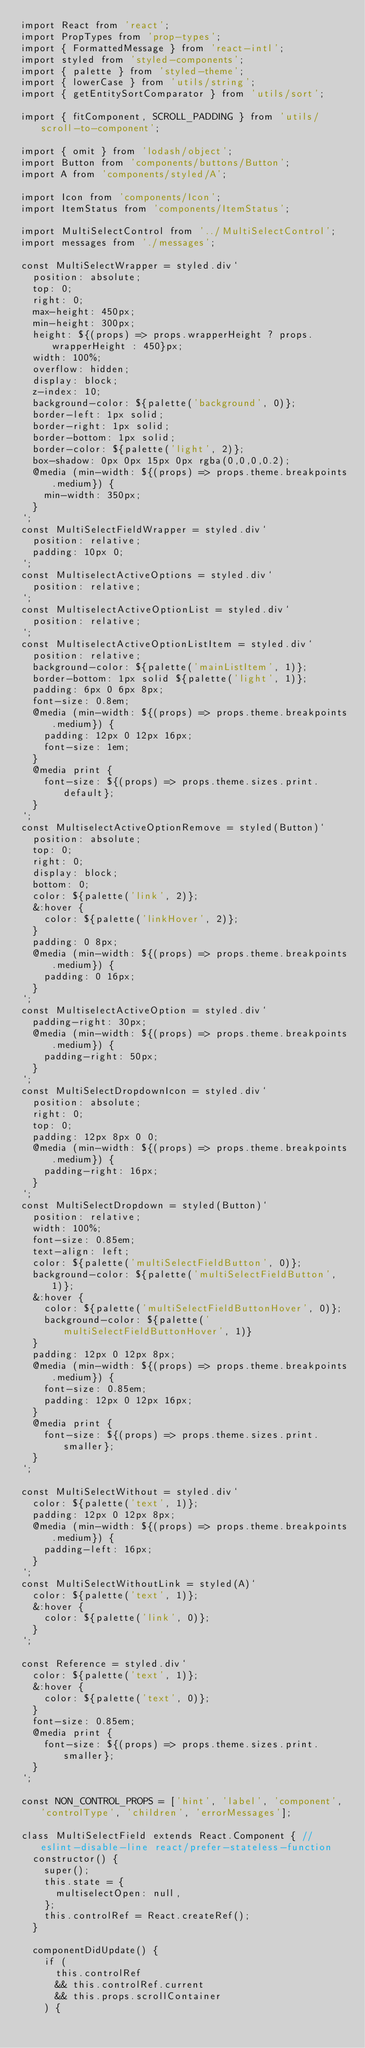<code> <loc_0><loc_0><loc_500><loc_500><_JavaScript_>import React from 'react';
import PropTypes from 'prop-types';
import { FormattedMessage } from 'react-intl';
import styled from 'styled-components';
import { palette } from 'styled-theme';
import { lowerCase } from 'utils/string';
import { getEntitySortComparator } from 'utils/sort';

import { fitComponent, SCROLL_PADDING } from 'utils/scroll-to-component';

import { omit } from 'lodash/object';
import Button from 'components/buttons/Button';
import A from 'components/styled/A';

import Icon from 'components/Icon';
import ItemStatus from 'components/ItemStatus';

import MultiSelectControl from '../MultiSelectControl';
import messages from './messages';

const MultiSelectWrapper = styled.div`
  position: absolute;
  top: 0;
  right: 0;
  max-height: 450px;
  min-height: 300px;
  height: ${(props) => props.wrapperHeight ? props.wrapperHeight : 450}px;
  width: 100%;
  overflow: hidden;
  display: block;
  z-index: 10;
  background-color: ${palette('background', 0)};
  border-left: 1px solid;
  border-right: 1px solid;
  border-bottom: 1px solid;
  border-color: ${palette('light', 2)};
  box-shadow: 0px 0px 15px 0px rgba(0,0,0,0.2);
  @media (min-width: ${(props) => props.theme.breakpoints.medium}) {
    min-width: 350px;
  }
`;
const MultiSelectFieldWrapper = styled.div`
  position: relative;
  padding: 10px 0;
`;
const MultiselectActiveOptions = styled.div`
  position: relative;
`;
const MultiselectActiveOptionList = styled.div`
  position: relative;
`;
const MultiselectActiveOptionListItem = styled.div`
  position: relative;
  background-color: ${palette('mainListItem', 1)};
  border-bottom: 1px solid ${palette('light', 1)};
  padding: 6px 0 6px 8px;
  font-size: 0.8em;
  @media (min-width: ${(props) => props.theme.breakpoints.medium}) {
    padding: 12px 0 12px 16px;
    font-size: 1em;
  }
  @media print {
    font-size: ${(props) => props.theme.sizes.print.default};
  }
`;
const MultiselectActiveOptionRemove = styled(Button)`
  position: absolute;
  top: 0;
  right: 0;
  display: block;
  bottom: 0;
  color: ${palette('link', 2)};
  &:hover {
    color: ${palette('linkHover', 2)};
  }
  padding: 0 8px;
  @media (min-width: ${(props) => props.theme.breakpoints.medium}) {
    padding: 0 16px;
  }
`;
const MultiselectActiveOption = styled.div`
  padding-right: 30px;
  @media (min-width: ${(props) => props.theme.breakpoints.medium}) {
    padding-right: 50px;
  }
`;
const MultiSelectDropdownIcon = styled.div`
  position: absolute;
  right: 0;
  top: 0;
  padding: 12px 8px 0 0;
  @media (min-width: ${(props) => props.theme.breakpoints.medium}) {
    padding-right: 16px;
  }
`;
const MultiSelectDropdown = styled(Button)`
  position: relative;
  width: 100%;
  font-size: 0.85em;
  text-align: left;
  color: ${palette('multiSelectFieldButton', 0)};
  background-color: ${palette('multiSelectFieldButton', 1)};
  &:hover {
    color: ${palette('multiSelectFieldButtonHover', 0)};
    background-color: ${palette('multiSelectFieldButtonHover', 1)}
  }
  padding: 12px 0 12px 8px;
  @media (min-width: ${(props) => props.theme.breakpoints.medium}) {
    font-size: 0.85em;
    padding: 12px 0 12px 16px;
  }
  @media print {
    font-size: ${(props) => props.theme.sizes.print.smaller};
  }
`;

const MultiSelectWithout = styled.div`
  color: ${palette('text', 1)};
  padding: 12px 0 12px 8px;
  @media (min-width: ${(props) => props.theme.breakpoints.medium}) {
    padding-left: 16px;
  }
`;
const MultiSelectWithoutLink = styled(A)`
  color: ${palette('text', 1)};
  &:hover {
    color: ${palette('link', 0)};
  }
`;

const Reference = styled.div`
  color: ${palette('text', 1)};
  &:hover {
    color: ${palette('text', 0)};
  }
  font-size: 0.85em;
  @media print {
    font-size: ${(props) => props.theme.sizes.print.smaller};
  }
`;

const NON_CONTROL_PROPS = ['hint', 'label', 'component', 'controlType', 'children', 'errorMessages'];

class MultiSelectField extends React.Component { // eslint-disable-line react/prefer-stateless-function
  constructor() {
    super();
    this.state = {
      multiselectOpen: null,
    };
    this.controlRef = React.createRef();
  }

  componentDidUpdate() {
    if (
      this.controlRef
      && this.controlRef.current
      && this.props.scrollContainer
    ) {</code> 